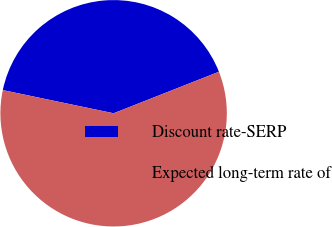Convert chart to OTSL. <chart><loc_0><loc_0><loc_500><loc_500><pie_chart><fcel>Discount rate-SERP<fcel>Expected long-term rate of<nl><fcel>40.74%<fcel>59.26%<nl></chart> 